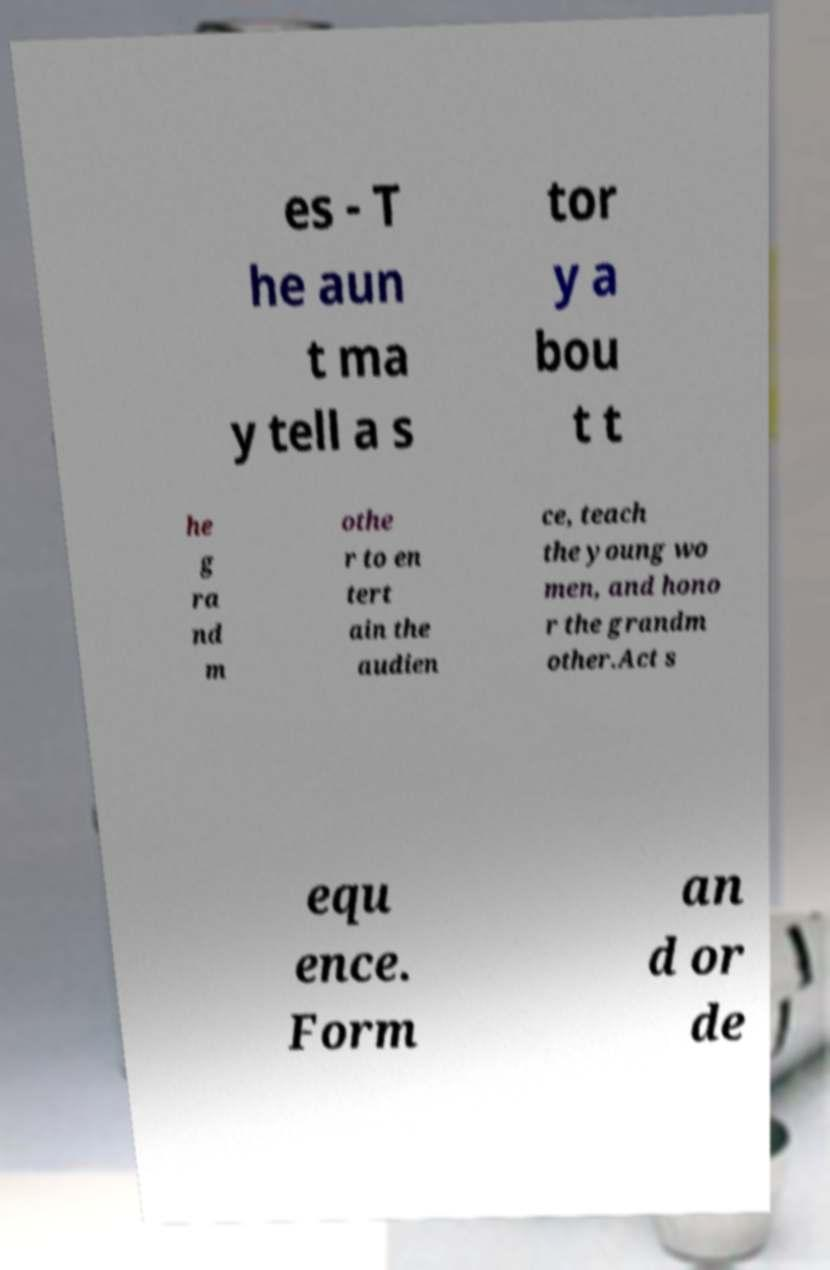There's text embedded in this image that I need extracted. Can you transcribe it verbatim? es - T he aun t ma y tell a s tor y a bou t t he g ra nd m othe r to en tert ain the audien ce, teach the young wo men, and hono r the grandm other.Act s equ ence. Form an d or de 